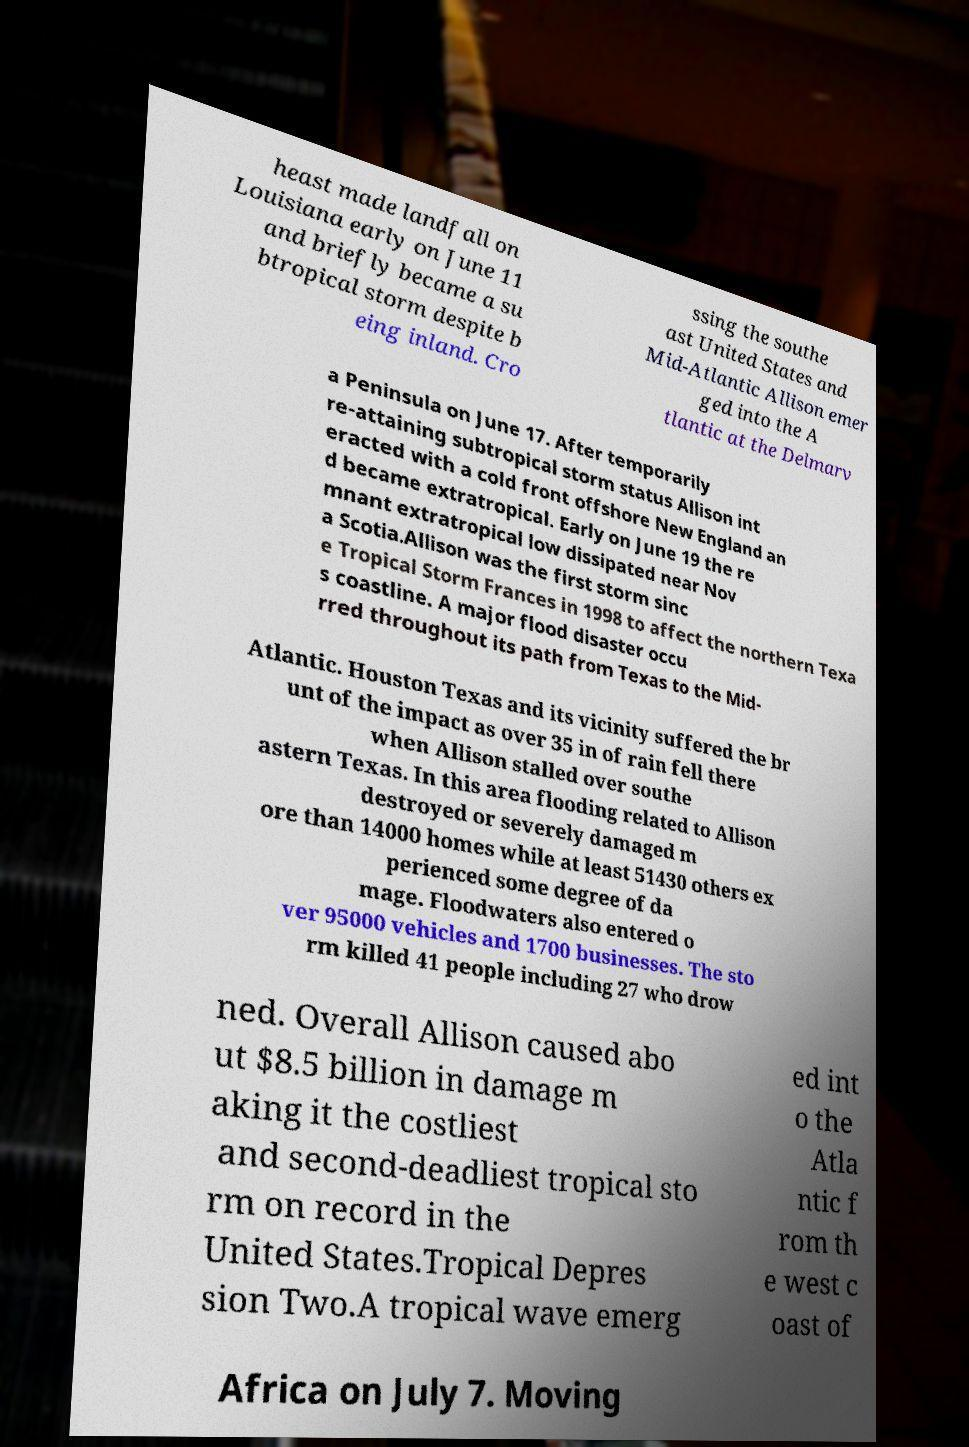Can you accurately transcribe the text from the provided image for me? heast made landfall on Louisiana early on June 11 and briefly became a su btropical storm despite b eing inland. Cro ssing the southe ast United States and Mid-Atlantic Allison emer ged into the A tlantic at the Delmarv a Peninsula on June 17. After temporarily re-attaining subtropical storm status Allison int eracted with a cold front offshore New England an d became extratropical. Early on June 19 the re mnant extratropical low dissipated near Nov a Scotia.Allison was the first storm sinc e Tropical Storm Frances in 1998 to affect the northern Texa s coastline. A major flood disaster occu rred throughout its path from Texas to the Mid- Atlantic. Houston Texas and its vicinity suffered the br unt of the impact as over 35 in of rain fell there when Allison stalled over southe astern Texas. In this area flooding related to Allison destroyed or severely damaged m ore than 14000 homes while at least 51430 others ex perienced some degree of da mage. Floodwaters also entered o ver 95000 vehicles and 1700 businesses. The sto rm killed 41 people including 27 who drow ned. Overall Allison caused abo ut $8.5 billion in damage m aking it the costliest and second-deadliest tropical sto rm on record in the United States.Tropical Depres sion Two.A tropical wave emerg ed int o the Atla ntic f rom th e west c oast of Africa on July 7. Moving 